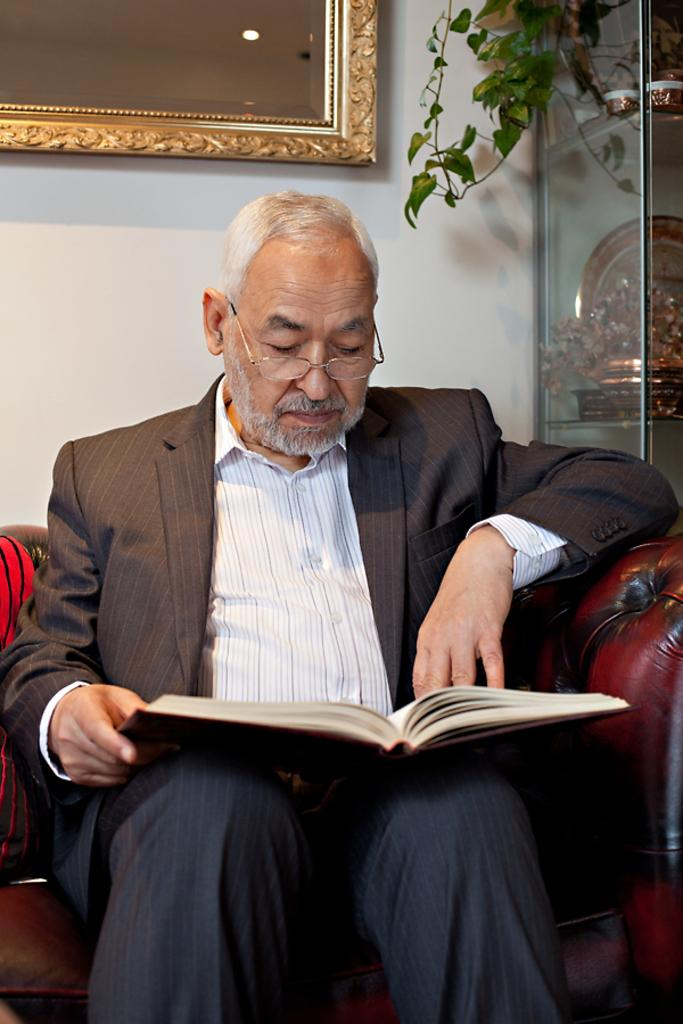What is the person in the image doing? The person is sitting on a sofa and reading a book. What can be seen behind the person? There is a wall behind the person. What is on the wall? There is a mirror on the wall. What type of flooring is visible in the image? There is a creep (possibly a typo for "carpet" or "creeper plant") in the image. Reasoning: Let' Let's think step by step in order to produce the conversation. We start by identifying the main subject in the image, which is the person sitting on the sofa. Then, we describe what the person is doing, which is reading a book. Next, we mention the wall behind the person and the mirror on the wall. Finally, we address the flooring in the image, which is described as a creep (possibly a typo for "carpet" or "creeper plant"). Each question is designed to elicit a specific detail about the image that is known from the provided facts. Absurd Question/Answer: What type of music is the person playing on the guitar in the image? There is no guitar present in the image; the person is reading a book. Can you tell me the content of the letter the person is writing in the image? There is no letter present in the image; the person is reading a book. 